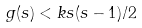Convert formula to latex. <formula><loc_0><loc_0><loc_500><loc_500>g ( s ) < k s ( s - 1 ) / 2</formula> 